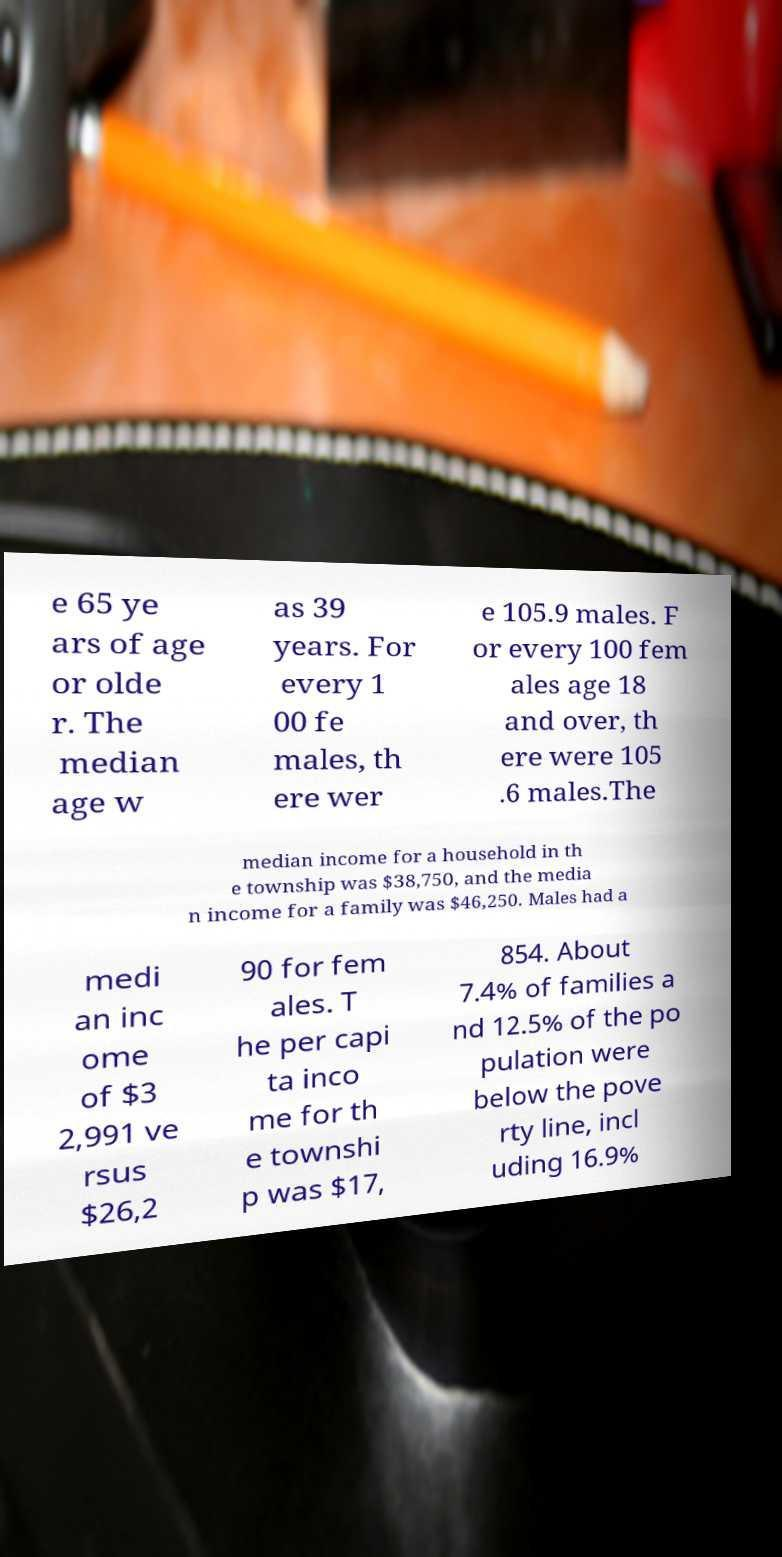Can you accurately transcribe the text from the provided image for me? e 65 ye ars of age or olde r. The median age w as 39 years. For every 1 00 fe males, th ere wer e 105.9 males. F or every 100 fem ales age 18 and over, th ere were 105 .6 males.The median income for a household in th e township was $38,750, and the media n income for a family was $46,250. Males had a medi an inc ome of $3 2,991 ve rsus $26,2 90 for fem ales. T he per capi ta inco me for th e townshi p was $17, 854. About 7.4% of families a nd 12.5% of the po pulation were below the pove rty line, incl uding 16.9% 